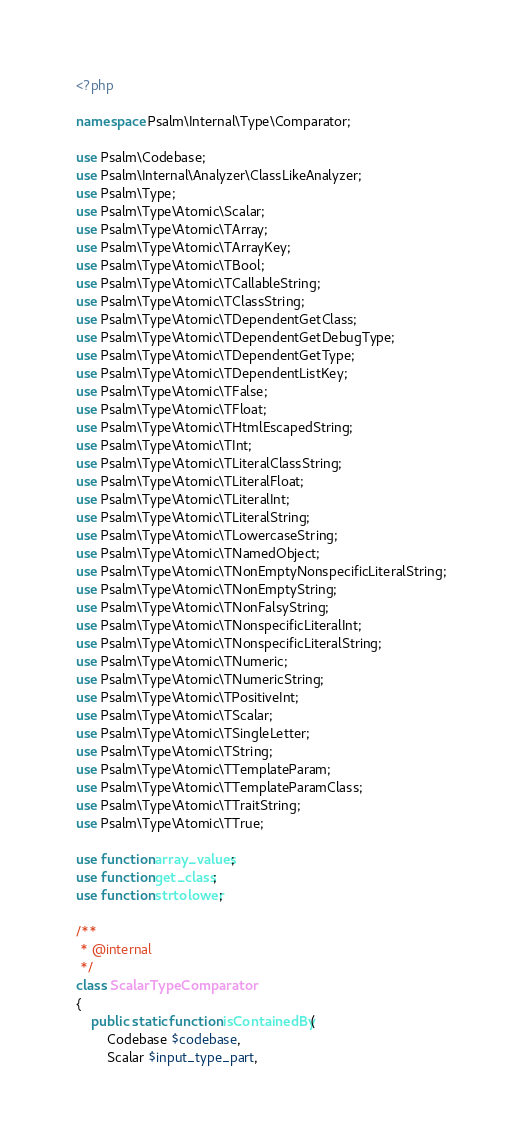Convert code to text. <code><loc_0><loc_0><loc_500><loc_500><_PHP_><?php

namespace Psalm\Internal\Type\Comparator;

use Psalm\Codebase;
use Psalm\Internal\Analyzer\ClassLikeAnalyzer;
use Psalm\Type;
use Psalm\Type\Atomic\Scalar;
use Psalm\Type\Atomic\TArray;
use Psalm\Type\Atomic\TArrayKey;
use Psalm\Type\Atomic\TBool;
use Psalm\Type\Atomic\TCallableString;
use Psalm\Type\Atomic\TClassString;
use Psalm\Type\Atomic\TDependentGetClass;
use Psalm\Type\Atomic\TDependentGetDebugType;
use Psalm\Type\Atomic\TDependentGetType;
use Psalm\Type\Atomic\TDependentListKey;
use Psalm\Type\Atomic\TFalse;
use Psalm\Type\Atomic\TFloat;
use Psalm\Type\Atomic\THtmlEscapedString;
use Psalm\Type\Atomic\TInt;
use Psalm\Type\Atomic\TLiteralClassString;
use Psalm\Type\Atomic\TLiteralFloat;
use Psalm\Type\Atomic\TLiteralInt;
use Psalm\Type\Atomic\TLiteralString;
use Psalm\Type\Atomic\TLowercaseString;
use Psalm\Type\Atomic\TNamedObject;
use Psalm\Type\Atomic\TNonEmptyNonspecificLiteralString;
use Psalm\Type\Atomic\TNonEmptyString;
use Psalm\Type\Atomic\TNonFalsyString;
use Psalm\Type\Atomic\TNonspecificLiteralInt;
use Psalm\Type\Atomic\TNonspecificLiteralString;
use Psalm\Type\Atomic\TNumeric;
use Psalm\Type\Atomic\TNumericString;
use Psalm\Type\Atomic\TPositiveInt;
use Psalm\Type\Atomic\TScalar;
use Psalm\Type\Atomic\TSingleLetter;
use Psalm\Type\Atomic\TString;
use Psalm\Type\Atomic\TTemplateParam;
use Psalm\Type\Atomic\TTemplateParamClass;
use Psalm\Type\Atomic\TTraitString;
use Psalm\Type\Atomic\TTrue;

use function array_values;
use function get_class;
use function strtolower;

/**
 * @internal
 */
class ScalarTypeComparator
{
    public static function isContainedBy(
        Codebase $codebase,
        Scalar $input_type_part,</code> 